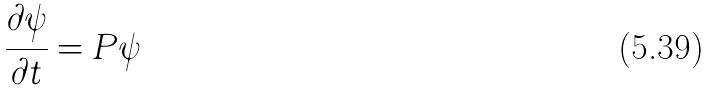<formula> <loc_0><loc_0><loc_500><loc_500>\frac { \partial \psi } { \partial t } = P \psi</formula> 